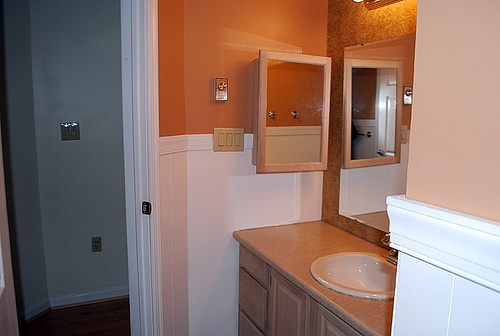Describe the objects in this image and their specific colors. I can see a sink in black, darkgray, gray, and tan tones in this image. 